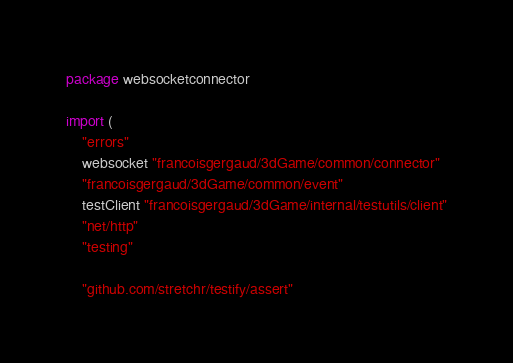Convert code to text. <code><loc_0><loc_0><loc_500><loc_500><_Go_>package websocketconnector

import (
	"errors"
	websocket "francoisgergaud/3dGame/common/connector"
	"francoisgergaud/3dGame/common/event"
	testClient "francoisgergaud/3dGame/internal/testutils/client"
	"net/http"
	"testing"

	"github.com/stretchr/testify/assert"</code> 